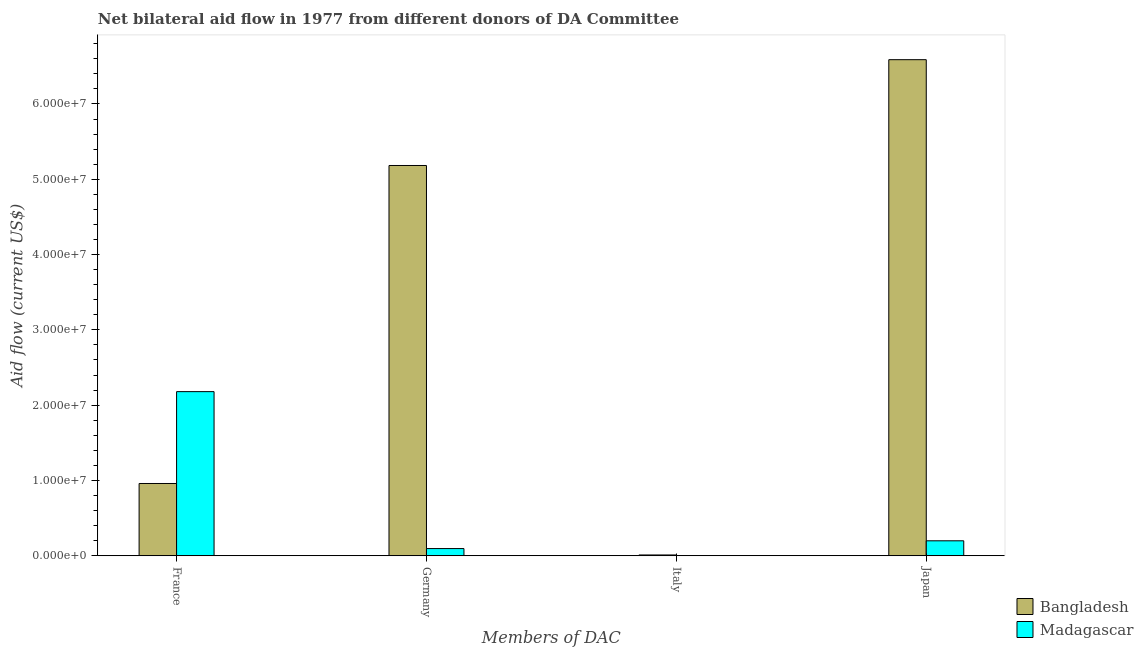How many different coloured bars are there?
Keep it short and to the point. 2. How many bars are there on the 1st tick from the right?
Your answer should be compact. 2. What is the amount of aid given by france in Madagascar?
Give a very brief answer. 2.18e+07. Across all countries, what is the maximum amount of aid given by italy?
Keep it short and to the point. 1.10e+05. Across all countries, what is the minimum amount of aid given by france?
Give a very brief answer. 9.60e+06. In which country was the amount of aid given by france maximum?
Offer a very short reply. Madagascar. What is the total amount of aid given by germany in the graph?
Provide a short and direct response. 5.28e+07. What is the difference between the amount of aid given by france in Bangladesh and that in Madagascar?
Your answer should be very brief. -1.22e+07. What is the difference between the amount of aid given by germany in Madagascar and the amount of aid given by italy in Bangladesh?
Offer a very short reply. 8.50e+05. What is the average amount of aid given by germany per country?
Offer a terse response. 2.64e+07. What is the difference between the amount of aid given by germany and amount of aid given by france in Bangladesh?
Keep it short and to the point. 4.22e+07. What is the ratio of the amount of aid given by japan in Bangladesh to that in Madagascar?
Your answer should be compact. 33.11. Is the difference between the amount of aid given by france in Madagascar and Bangladesh greater than the difference between the amount of aid given by germany in Madagascar and Bangladesh?
Keep it short and to the point. Yes. What is the difference between the highest and the second highest amount of aid given by france?
Your answer should be compact. 1.22e+07. What is the difference between the highest and the lowest amount of aid given by japan?
Your answer should be very brief. 6.39e+07. Is the sum of the amount of aid given by germany in Madagascar and Bangladesh greater than the maximum amount of aid given by italy across all countries?
Your response must be concise. Yes. How many countries are there in the graph?
Offer a terse response. 2. What is the difference between two consecutive major ticks on the Y-axis?
Your answer should be very brief. 1.00e+07. Does the graph contain any zero values?
Offer a very short reply. Yes. How many legend labels are there?
Make the answer very short. 2. What is the title of the graph?
Offer a terse response. Net bilateral aid flow in 1977 from different donors of DA Committee. Does "Kiribati" appear as one of the legend labels in the graph?
Offer a terse response. No. What is the label or title of the X-axis?
Provide a succinct answer. Members of DAC. What is the label or title of the Y-axis?
Make the answer very short. Aid flow (current US$). What is the Aid flow (current US$) in Bangladesh in France?
Offer a terse response. 9.60e+06. What is the Aid flow (current US$) of Madagascar in France?
Give a very brief answer. 2.18e+07. What is the Aid flow (current US$) in Bangladesh in Germany?
Your answer should be very brief. 5.18e+07. What is the Aid flow (current US$) of Madagascar in Germany?
Offer a terse response. 9.60e+05. What is the Aid flow (current US$) in Madagascar in Italy?
Provide a succinct answer. 0. What is the Aid flow (current US$) in Bangladesh in Japan?
Ensure brevity in your answer.  6.59e+07. What is the Aid flow (current US$) in Madagascar in Japan?
Make the answer very short. 1.99e+06. Across all Members of DAC, what is the maximum Aid flow (current US$) of Bangladesh?
Your answer should be very brief. 6.59e+07. Across all Members of DAC, what is the maximum Aid flow (current US$) of Madagascar?
Your response must be concise. 2.18e+07. Across all Members of DAC, what is the minimum Aid flow (current US$) of Madagascar?
Offer a very short reply. 0. What is the total Aid flow (current US$) of Bangladesh in the graph?
Provide a short and direct response. 1.27e+08. What is the total Aid flow (current US$) in Madagascar in the graph?
Give a very brief answer. 2.48e+07. What is the difference between the Aid flow (current US$) of Bangladesh in France and that in Germany?
Offer a terse response. -4.22e+07. What is the difference between the Aid flow (current US$) of Madagascar in France and that in Germany?
Offer a very short reply. 2.08e+07. What is the difference between the Aid flow (current US$) in Bangladesh in France and that in Italy?
Offer a terse response. 9.49e+06. What is the difference between the Aid flow (current US$) in Bangladesh in France and that in Japan?
Provide a short and direct response. -5.63e+07. What is the difference between the Aid flow (current US$) of Madagascar in France and that in Japan?
Your answer should be compact. 1.98e+07. What is the difference between the Aid flow (current US$) in Bangladesh in Germany and that in Italy?
Offer a terse response. 5.17e+07. What is the difference between the Aid flow (current US$) of Bangladesh in Germany and that in Japan?
Provide a short and direct response. -1.40e+07. What is the difference between the Aid flow (current US$) in Madagascar in Germany and that in Japan?
Provide a succinct answer. -1.03e+06. What is the difference between the Aid flow (current US$) of Bangladesh in Italy and that in Japan?
Your answer should be compact. -6.58e+07. What is the difference between the Aid flow (current US$) of Bangladesh in France and the Aid flow (current US$) of Madagascar in Germany?
Make the answer very short. 8.64e+06. What is the difference between the Aid flow (current US$) in Bangladesh in France and the Aid flow (current US$) in Madagascar in Japan?
Offer a terse response. 7.61e+06. What is the difference between the Aid flow (current US$) of Bangladesh in Germany and the Aid flow (current US$) of Madagascar in Japan?
Offer a very short reply. 4.98e+07. What is the difference between the Aid flow (current US$) in Bangladesh in Italy and the Aid flow (current US$) in Madagascar in Japan?
Keep it short and to the point. -1.88e+06. What is the average Aid flow (current US$) in Bangladesh per Members of DAC?
Give a very brief answer. 3.19e+07. What is the average Aid flow (current US$) of Madagascar per Members of DAC?
Your response must be concise. 6.19e+06. What is the difference between the Aid flow (current US$) in Bangladesh and Aid flow (current US$) in Madagascar in France?
Make the answer very short. -1.22e+07. What is the difference between the Aid flow (current US$) of Bangladesh and Aid flow (current US$) of Madagascar in Germany?
Give a very brief answer. 5.09e+07. What is the difference between the Aid flow (current US$) in Bangladesh and Aid flow (current US$) in Madagascar in Japan?
Make the answer very short. 6.39e+07. What is the ratio of the Aid flow (current US$) of Bangladesh in France to that in Germany?
Keep it short and to the point. 0.19. What is the ratio of the Aid flow (current US$) in Madagascar in France to that in Germany?
Ensure brevity in your answer.  22.71. What is the ratio of the Aid flow (current US$) of Bangladesh in France to that in Italy?
Give a very brief answer. 87.27. What is the ratio of the Aid flow (current US$) in Bangladesh in France to that in Japan?
Offer a very short reply. 0.15. What is the ratio of the Aid flow (current US$) of Madagascar in France to that in Japan?
Provide a succinct answer. 10.95. What is the ratio of the Aid flow (current US$) of Bangladesh in Germany to that in Italy?
Offer a very short reply. 471.18. What is the ratio of the Aid flow (current US$) in Bangladesh in Germany to that in Japan?
Provide a succinct answer. 0.79. What is the ratio of the Aid flow (current US$) in Madagascar in Germany to that in Japan?
Make the answer very short. 0.48. What is the ratio of the Aid flow (current US$) of Bangladesh in Italy to that in Japan?
Offer a very short reply. 0. What is the difference between the highest and the second highest Aid flow (current US$) of Bangladesh?
Ensure brevity in your answer.  1.40e+07. What is the difference between the highest and the second highest Aid flow (current US$) of Madagascar?
Your response must be concise. 1.98e+07. What is the difference between the highest and the lowest Aid flow (current US$) of Bangladesh?
Ensure brevity in your answer.  6.58e+07. What is the difference between the highest and the lowest Aid flow (current US$) of Madagascar?
Offer a terse response. 2.18e+07. 